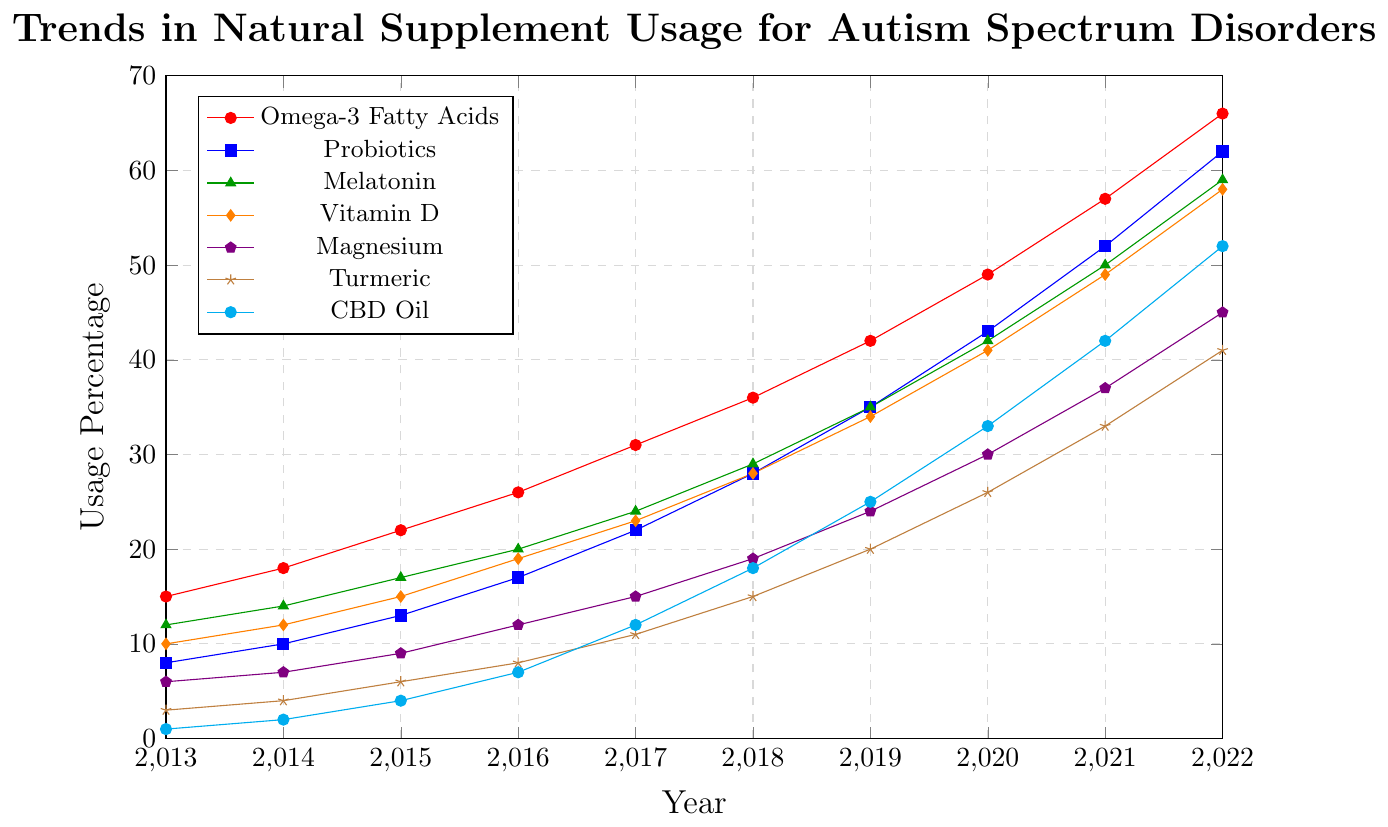Which supplement showed the highest usage in 2022? According to the chart, in 2022, the highest percentage usage is shown by Omega-3 Fatty Acids, with values reaching 66.
Answer: Omega-3 Fatty Acids How much did the usage of CBD Oil increase from 2013 to 2022? The chart shows that in 2013, the CBD Oil usage was 1%, and by 2022, it increased to 52%. The difference between these values is calculated as 52 - 1 = 51.
Answer: 51 Which year saw the largest percentage increase in Probiotics usage compared to the previous year? By examining the incremental changes each year, the highest increase for Probiotics appears between 2021 (52%) and 2022 (62%). The difference is 62 - 52 = 10.
Answer: 2022 Among Omega-3 Fatty Acids and Vitamin D, which supplement had a higher usage growth between 2017 and 2018? From the chart, Omega-3 Fatty Acids increased from 31% in 2017 to 36% in 2018 (an increase of 5%), while Vitamin D increased from 23% in 2017 to 28% in 2018 (also an increase of 5%). Both show equal growth.
Answer: Both What is the average usage percentage of Melatonin over the decade? To find the average, sum the Melatonin values over the years: 12 + 14 + 17 + 20 + 24 + 29 + 35 + 42 + 50 + 59 = 302. Divide this by the number of years, 302 / 10 = 30.2.
Answer: 30.2 Which supplement experienced the fastest growth rate between 2020 and 2021? By examining the differences between 2021 and 2020 for each supplement: Omega-3 Fatty Acids (57-49=8), Probiotics (52-43=9), Melatonin (50-42=8), Vitamin D (49-41=8), Magnesium (37-30=7), Turmeric (33-26=7), CBD Oil (42-33=9). Probiotics and CBD Oil both show the highest growth rate, of 9%.
Answer: Probiotics and CBD Oil Which supplement had the lowest usage percentage in 2013, and what was its percentage? Based on the chart, CBD Oil had the lowest usage percentage in 2013 at 1%.
Answer: CBD Oil, 1% How do the trends of Vitamin D and Magnesium usage compare over the decade? Both supplements show an increasing trend. Vitamin D increased from 10% in 2013 to 58% in 2022, while Magnesium increased from 6% in 2013 to 45% in 2022. Both have steady growth with similar patterns, but Vitamin D consistently had higher values each year.
Answer: Both show increasing trends, with Vitamin D consistently higher Which supplement had the largest absolute increment in usage from 2013 to 2015? From the chart: Omega-3 Fatty Acids increment (22-15=7), Probiotics (13-8=5), Melatonin (17-12=5), Vitamin D (15-10=5), Magnesium (9-6=3), Turmeric (6-3=3), CBD Oil (4-1=3). Omega-3 Fatty Acids had the largest increment of 7.
Answer: Omega-3 Fatty Acids 